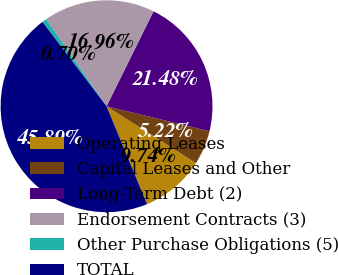Convert chart. <chart><loc_0><loc_0><loc_500><loc_500><pie_chart><fcel>Operating Leases<fcel>Capital Leases and Other<fcel>Long-Term Debt (2)<fcel>Endorsement Contracts (3)<fcel>Other Purchase Obligations (5)<fcel>TOTAL<nl><fcel>9.74%<fcel>5.22%<fcel>21.48%<fcel>16.96%<fcel>0.7%<fcel>45.89%<nl></chart> 